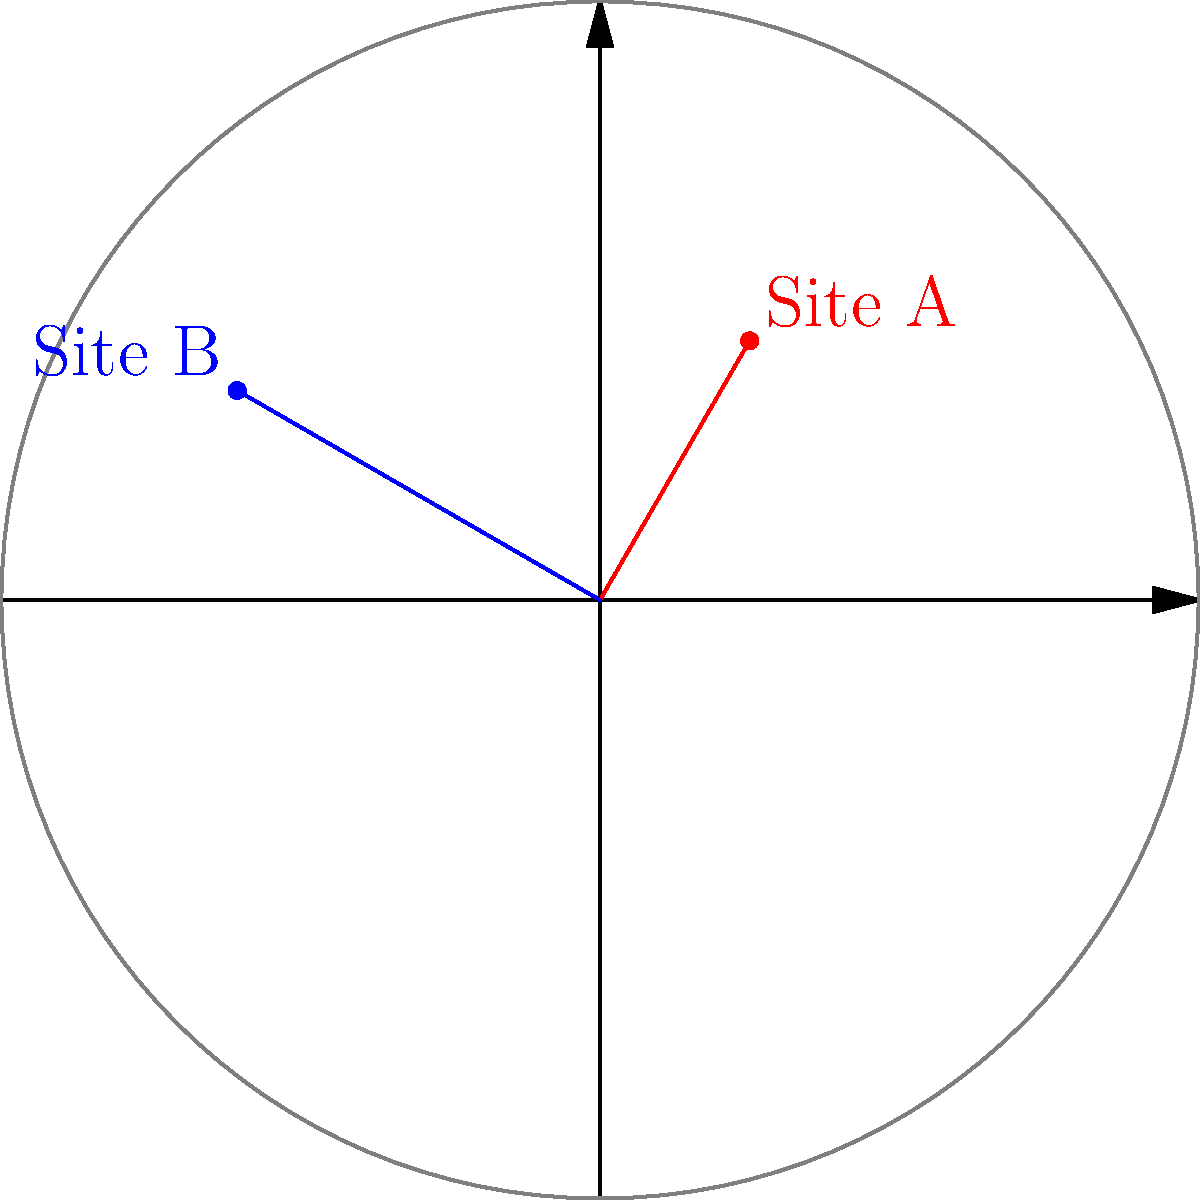Two archaeological dig sites, A and B, are located on a map using polar coordinates. Site A is at $(5, \frac{\pi}{3})$ and Site B is at $(7, \frac{5\pi}{6})$. Calculate the distance between these two sites to the nearest tenth of a unit. To find the distance between two points in polar coordinates, we can follow these steps:

1) Convert the polar coordinates to Cartesian coordinates:
   For Site A: $(r_1, \theta_1) = (5, \frac{\pi}{3})$
   $x_1 = r_1 \cos(\theta_1) = 5 \cos(\frac{\pi}{3}) = 2.5$
   $y_1 = r_1 \sin(\theta_1) = 5 \sin(\frac{\pi}{3}) = 4.33$

   For Site B: $(r_2, \theta_2) = (7, \frac{5\pi}{6})$
   $x_2 = r_2 \cos(\theta_2) = 7 \cos(\frac{5\pi}{6}) = -6.06$
   $y_2 = r_2 \sin(\theta_2) = 7 \sin(\frac{5\pi}{6}) = 3.5$

2) Use the distance formula between two points in Cartesian coordinates:
   $d = \sqrt{(x_2-x_1)^2 + (y_2-y_1)^2}$

3) Plug in the values:
   $d = \sqrt{(-6.06-2.5)^2 + (3.5-4.33)^2}$
   $d = \sqrt{(-8.56)^2 + (-0.83)^2}$
   $d = \sqrt{73.2736 + 0.6889}$
   $d = \sqrt{73.9625}$
   $d \approx 8.6$

Therefore, the distance between the two dig sites is approximately 8.6 units.
Answer: 8.6 units 